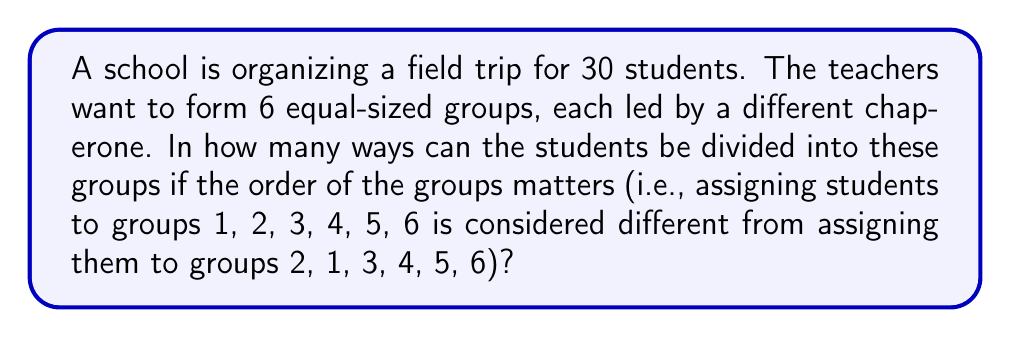Provide a solution to this math problem. Let's approach this step-by-step:

1) First, we need to recognize that this is a partition problem. We're partitioning 30 students into 6 equal groups.

2) The number of ways to partition n distinct objects into k distinct groups is given by the formula:

   $$\frac{n!}{(n/k)!^k}$$

3) In our case:
   n = 30 (total number of students)
   k = 6 (number of groups)
   n/k = 5 (number of students in each group)

4) Substituting these values into the formula:

   $$\frac{30!}{(5!)^6}$$

5) This can be calculated as follows:

   $$\frac{30 \cdot 29 \cdot 28 \cdot 27 \cdot 26 \cdot 25 \cdot 24 \cdot 23 \cdot 22 \cdot 21 \cdot 20 \cdot 19 \cdot 18 \cdot 17 \cdot 16 \cdot 15 \cdot 14 \cdot 13 \cdot 12 \cdot 11 \cdot 10 \cdot 9 \cdot 8 \cdot 7 \cdot 6 \cdot 5!}{(5!)^6}$$

6) Simplifying:

   $$\frac{30 \cdot 29 \cdot 28 \cdot 27 \cdot 26 \cdot 25 \cdot 24 \cdot 23 \cdot 22 \cdot 21 \cdot 20 \cdot 19 \cdot 18 \cdot 17 \cdot 16 \cdot 15 \cdot 14 \cdot 13 \cdot 12 \cdot 11 \cdot 10 \cdot 9 \cdot 8 \cdot 7 \cdot 6}{(5!)^5}$$

7) This evaluates to a very large number:

   $$\text{37,837,835,702,510,469,376,000}$$

This represents the number of ways to divide 30 students into 6 equal-sized groups where the order of the groups matters.
Answer: 37,837,835,702,510,469,376,000 